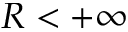Convert formula to latex. <formula><loc_0><loc_0><loc_500><loc_500>R < + \infty</formula> 